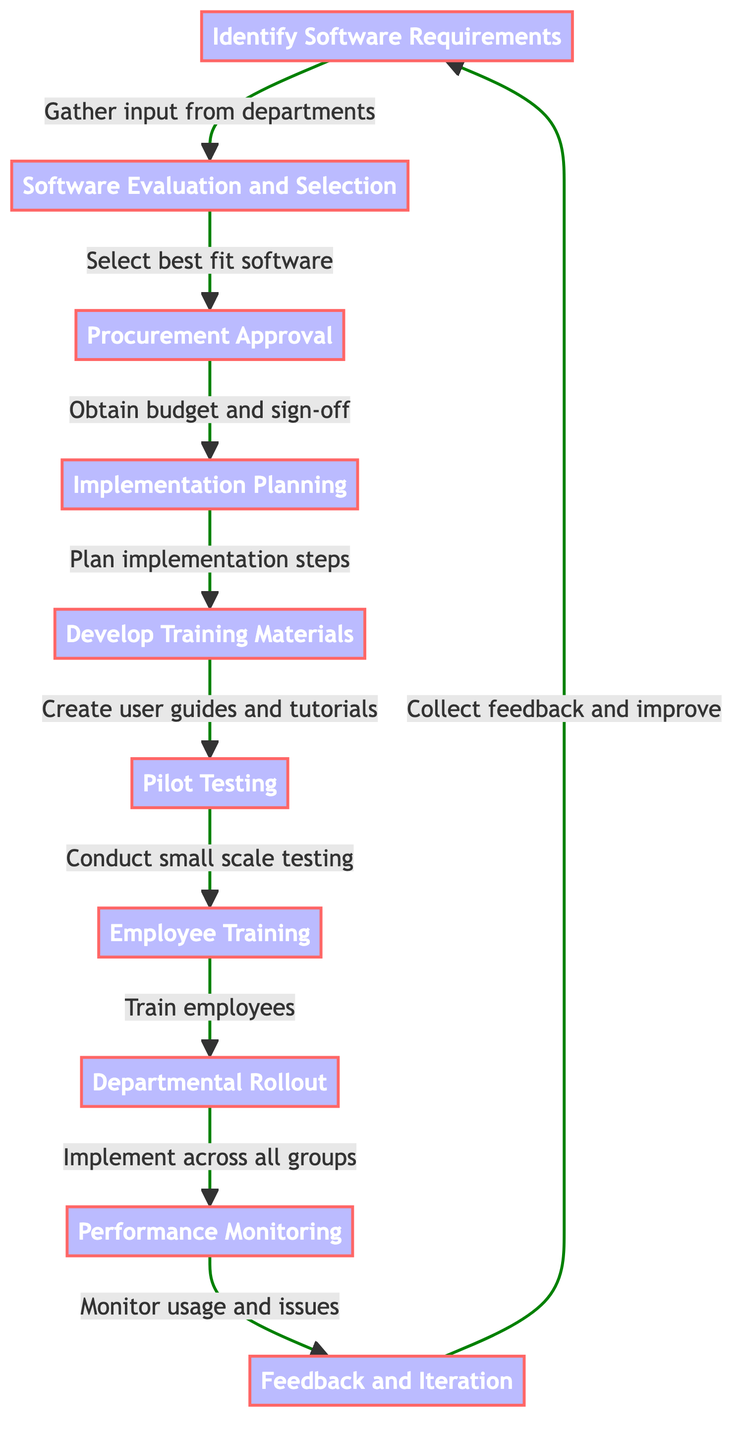What is the first step in the software adoption process? The first node in the directed graph is "Identify Software Requirements," indicating that this is the initial step in the process.
Answer: Identify Software Requirements How many total nodes are in the diagram? The diagram includes a total of 10 nodes representing distinct steps in the software adoption process.
Answer: 10 What is the relationship between "Employee Training" and "Pilot Testing"? In the directed graph, "Employee Training" (node 7) follows "Pilot Testing" (node 6), indicating that employee training is dependent on the completion of pilot testing.
Answer: Conduct small scale testing Which step comes after "Departmental Rollout"? Following "Departmental Rollout" (node 8), the next step in the process is "Performance Monitoring" (node 9), indicating the progression of activities.
Answer: Performance Monitoring What is the last step that feeds back into the first step? The final step in the sequence, "Feedback and Iteration" (node 10), loops back to the first step "Identify Software Requirements" (node 1), showing a cycle in the process.
Answer: Collect feedback and improve How many edges are outgoing from the "Implementation Planning" node? Analyzing the edges connected to "Implementation Planning" (node 4), there is one outgoing edge leading to "Develop Training Materials," meaning only one subsequent step arises from it.
Answer: 1 What are the main milestones in the training phase? In the training phase, the milestones are "Develop Training Materials," "Pilot Testing," and "Employee Training," representing the preparation and execution of training efforts in the process.
Answer: Develop Training Materials, Pilot Testing, Employee Training What feedback mechanism exists in this process? The process includes a feedback loop where "Feedback and Iteration" (node 10) is connected to "Identify Software Requirements" (node 1), indicating that the feedback collected will lead to reviewing and improving requirements.
Answer: Collect feedback and improve 